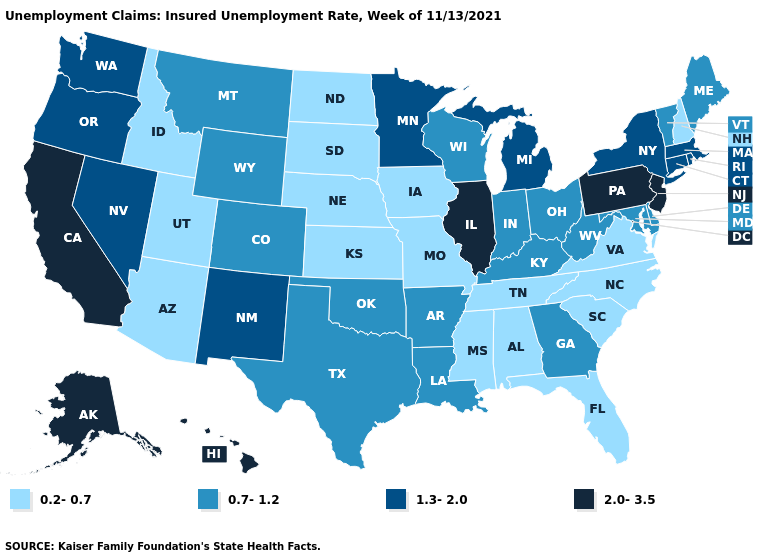Is the legend a continuous bar?
Be succinct. No. Among the states that border Washington , does Idaho have the lowest value?
Give a very brief answer. Yes. What is the value of Wyoming?
Quick response, please. 0.7-1.2. Name the states that have a value in the range 0.2-0.7?
Concise answer only. Alabama, Arizona, Florida, Idaho, Iowa, Kansas, Mississippi, Missouri, Nebraska, New Hampshire, North Carolina, North Dakota, South Carolina, South Dakota, Tennessee, Utah, Virginia. Name the states that have a value in the range 1.3-2.0?
Short answer required. Connecticut, Massachusetts, Michigan, Minnesota, Nevada, New Mexico, New York, Oregon, Rhode Island, Washington. Which states have the lowest value in the Northeast?
Give a very brief answer. New Hampshire. Does Washington have the highest value in the USA?
Give a very brief answer. No. Name the states that have a value in the range 2.0-3.5?
Write a very short answer. Alaska, California, Hawaii, Illinois, New Jersey, Pennsylvania. Among the states that border New Jersey , which have the highest value?
Be succinct. Pennsylvania. Does the first symbol in the legend represent the smallest category?
Concise answer only. Yes. Among the states that border Vermont , which have the highest value?
Short answer required. Massachusetts, New York. Name the states that have a value in the range 0.7-1.2?
Concise answer only. Arkansas, Colorado, Delaware, Georgia, Indiana, Kentucky, Louisiana, Maine, Maryland, Montana, Ohio, Oklahoma, Texas, Vermont, West Virginia, Wisconsin, Wyoming. Name the states that have a value in the range 0.2-0.7?
Short answer required. Alabama, Arizona, Florida, Idaho, Iowa, Kansas, Mississippi, Missouri, Nebraska, New Hampshire, North Carolina, North Dakota, South Carolina, South Dakota, Tennessee, Utah, Virginia. What is the highest value in the USA?
Be succinct. 2.0-3.5. Does the map have missing data?
Concise answer only. No. 